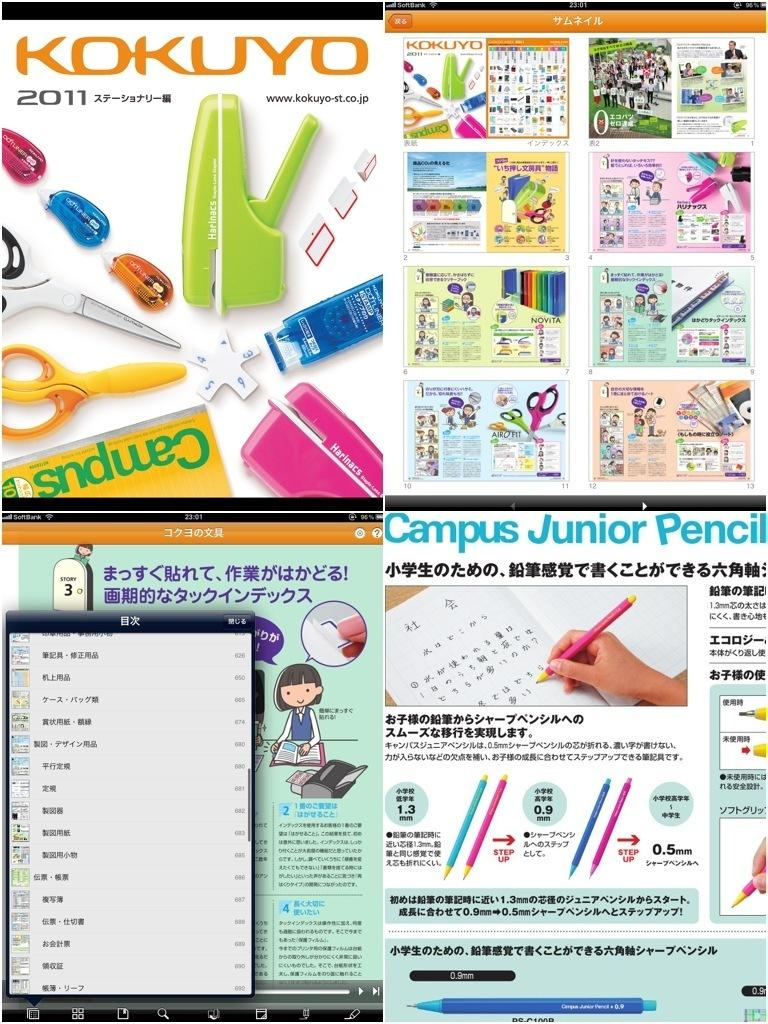Provide a one-sentence caption for the provided image. Kokuyo 2011 shows advertisements for school supplies such as Campus Junior Pencil. 